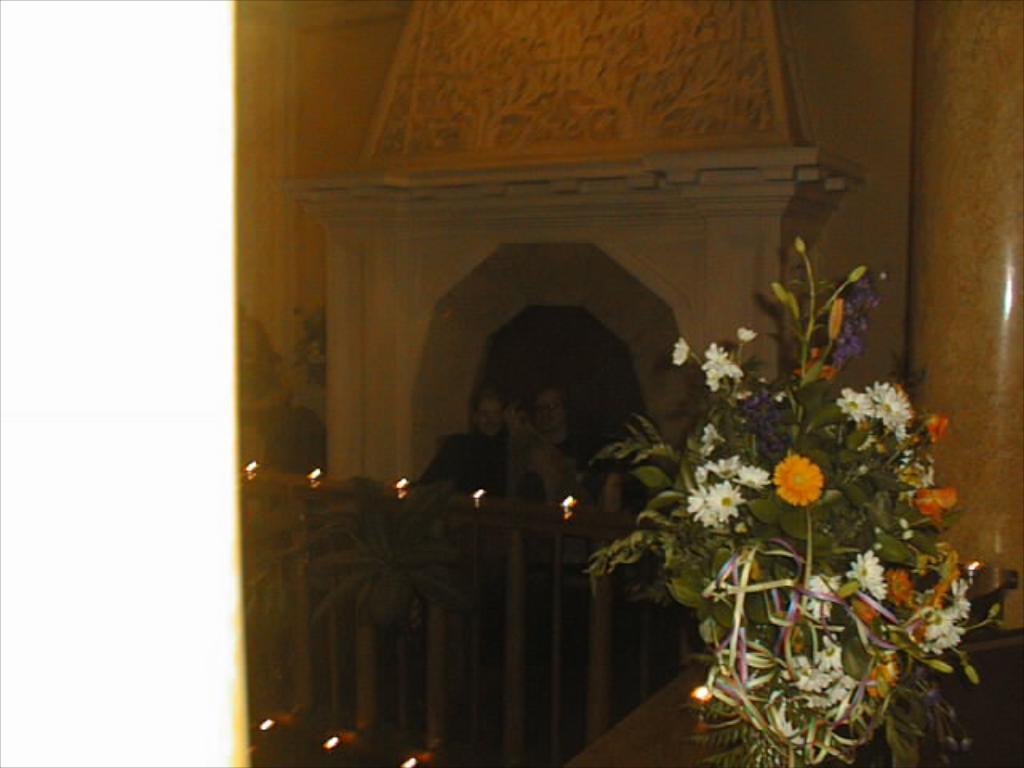Please provide a concise description of this image. In this image we can see a bouquet which is placed on the surface. We can also see the railing, lights, a plant and a pillar. We can also see some people standing beside the wall. 